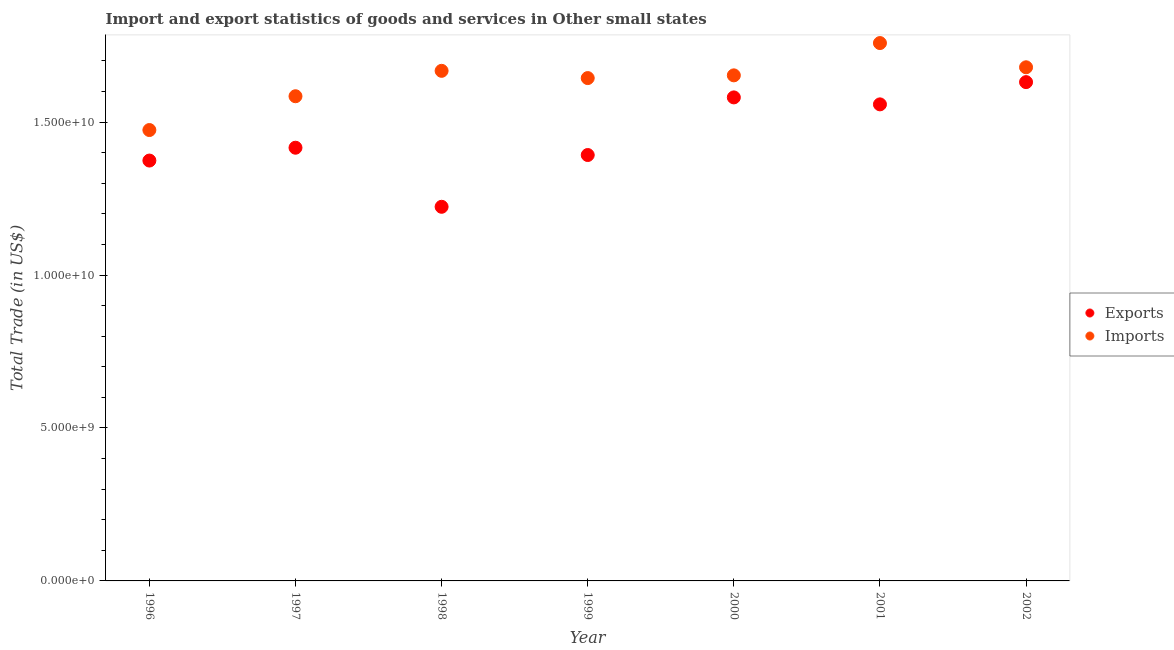How many different coloured dotlines are there?
Your answer should be compact. 2. Is the number of dotlines equal to the number of legend labels?
Make the answer very short. Yes. What is the export of goods and services in 2000?
Make the answer very short. 1.58e+1. Across all years, what is the maximum export of goods and services?
Provide a succinct answer. 1.63e+1. Across all years, what is the minimum export of goods and services?
Give a very brief answer. 1.22e+1. In which year was the imports of goods and services maximum?
Your response must be concise. 2001. In which year was the export of goods and services minimum?
Your answer should be very brief. 1998. What is the total imports of goods and services in the graph?
Provide a short and direct response. 1.15e+11. What is the difference between the imports of goods and services in 2000 and that in 2002?
Keep it short and to the point. -2.64e+08. What is the difference between the export of goods and services in 2001 and the imports of goods and services in 2002?
Your answer should be very brief. -1.21e+09. What is the average imports of goods and services per year?
Offer a terse response. 1.64e+1. In the year 2002, what is the difference between the imports of goods and services and export of goods and services?
Ensure brevity in your answer.  4.85e+08. In how many years, is the imports of goods and services greater than 1000000000 US$?
Your response must be concise. 7. What is the ratio of the export of goods and services in 1999 to that in 2001?
Offer a very short reply. 0.89. What is the difference between the highest and the second highest imports of goods and services?
Offer a terse response. 7.92e+08. What is the difference between the highest and the lowest export of goods and services?
Your answer should be compact. 4.08e+09. Is the sum of the export of goods and services in 1997 and 1999 greater than the maximum imports of goods and services across all years?
Offer a very short reply. Yes. Does the export of goods and services monotonically increase over the years?
Offer a terse response. No. Is the imports of goods and services strictly greater than the export of goods and services over the years?
Your response must be concise. Yes. Is the imports of goods and services strictly less than the export of goods and services over the years?
Offer a very short reply. No. How many dotlines are there?
Offer a very short reply. 2. How many years are there in the graph?
Make the answer very short. 7. Does the graph contain grids?
Your response must be concise. No. Where does the legend appear in the graph?
Your answer should be compact. Center right. How many legend labels are there?
Your answer should be compact. 2. How are the legend labels stacked?
Keep it short and to the point. Vertical. What is the title of the graph?
Provide a short and direct response. Import and export statistics of goods and services in Other small states. What is the label or title of the X-axis?
Give a very brief answer. Year. What is the label or title of the Y-axis?
Provide a short and direct response. Total Trade (in US$). What is the Total Trade (in US$) of Exports in 1996?
Your answer should be compact. 1.37e+1. What is the Total Trade (in US$) of Imports in 1996?
Give a very brief answer. 1.47e+1. What is the Total Trade (in US$) of Exports in 1997?
Your response must be concise. 1.42e+1. What is the Total Trade (in US$) in Imports in 1997?
Make the answer very short. 1.58e+1. What is the Total Trade (in US$) in Exports in 1998?
Ensure brevity in your answer.  1.22e+1. What is the Total Trade (in US$) in Imports in 1998?
Your answer should be compact. 1.67e+1. What is the Total Trade (in US$) of Exports in 1999?
Ensure brevity in your answer.  1.39e+1. What is the Total Trade (in US$) of Imports in 1999?
Keep it short and to the point. 1.64e+1. What is the Total Trade (in US$) in Exports in 2000?
Keep it short and to the point. 1.58e+1. What is the Total Trade (in US$) in Imports in 2000?
Your answer should be very brief. 1.65e+1. What is the Total Trade (in US$) in Exports in 2001?
Your response must be concise. 1.56e+1. What is the Total Trade (in US$) in Imports in 2001?
Your response must be concise. 1.76e+1. What is the Total Trade (in US$) in Exports in 2002?
Offer a terse response. 1.63e+1. What is the Total Trade (in US$) of Imports in 2002?
Give a very brief answer. 1.68e+1. Across all years, what is the maximum Total Trade (in US$) in Exports?
Offer a very short reply. 1.63e+1. Across all years, what is the maximum Total Trade (in US$) of Imports?
Offer a very short reply. 1.76e+1. Across all years, what is the minimum Total Trade (in US$) of Exports?
Provide a short and direct response. 1.22e+1. Across all years, what is the minimum Total Trade (in US$) in Imports?
Your answer should be compact. 1.47e+1. What is the total Total Trade (in US$) of Exports in the graph?
Keep it short and to the point. 1.02e+11. What is the total Total Trade (in US$) in Imports in the graph?
Ensure brevity in your answer.  1.15e+11. What is the difference between the Total Trade (in US$) of Exports in 1996 and that in 1997?
Your answer should be very brief. -4.20e+08. What is the difference between the Total Trade (in US$) of Imports in 1996 and that in 1997?
Make the answer very short. -1.10e+09. What is the difference between the Total Trade (in US$) of Exports in 1996 and that in 1998?
Your answer should be compact. 1.51e+09. What is the difference between the Total Trade (in US$) in Imports in 1996 and that in 1998?
Give a very brief answer. -1.94e+09. What is the difference between the Total Trade (in US$) of Exports in 1996 and that in 1999?
Make the answer very short. -1.81e+08. What is the difference between the Total Trade (in US$) of Imports in 1996 and that in 1999?
Your response must be concise. -1.70e+09. What is the difference between the Total Trade (in US$) of Exports in 1996 and that in 2000?
Your answer should be compact. -2.06e+09. What is the difference between the Total Trade (in US$) of Imports in 1996 and that in 2000?
Offer a terse response. -1.79e+09. What is the difference between the Total Trade (in US$) of Exports in 1996 and that in 2001?
Your response must be concise. -1.84e+09. What is the difference between the Total Trade (in US$) in Imports in 1996 and that in 2001?
Offer a terse response. -2.84e+09. What is the difference between the Total Trade (in US$) of Exports in 1996 and that in 2002?
Provide a short and direct response. -2.56e+09. What is the difference between the Total Trade (in US$) in Imports in 1996 and that in 2002?
Make the answer very short. -2.05e+09. What is the difference between the Total Trade (in US$) in Exports in 1997 and that in 1998?
Make the answer very short. 1.93e+09. What is the difference between the Total Trade (in US$) of Imports in 1997 and that in 1998?
Give a very brief answer. -8.31e+08. What is the difference between the Total Trade (in US$) in Exports in 1997 and that in 1999?
Provide a short and direct response. 2.39e+08. What is the difference between the Total Trade (in US$) of Imports in 1997 and that in 1999?
Keep it short and to the point. -5.94e+08. What is the difference between the Total Trade (in US$) in Exports in 1997 and that in 2000?
Offer a terse response. -1.65e+09. What is the difference between the Total Trade (in US$) of Imports in 1997 and that in 2000?
Your answer should be compact. -6.83e+08. What is the difference between the Total Trade (in US$) in Exports in 1997 and that in 2001?
Ensure brevity in your answer.  -1.42e+09. What is the difference between the Total Trade (in US$) of Imports in 1997 and that in 2001?
Ensure brevity in your answer.  -1.74e+09. What is the difference between the Total Trade (in US$) in Exports in 1997 and that in 2002?
Your response must be concise. -2.15e+09. What is the difference between the Total Trade (in US$) of Imports in 1997 and that in 2002?
Keep it short and to the point. -9.47e+08. What is the difference between the Total Trade (in US$) of Exports in 1998 and that in 1999?
Provide a succinct answer. -1.69e+09. What is the difference between the Total Trade (in US$) of Imports in 1998 and that in 1999?
Your answer should be very brief. 2.37e+08. What is the difference between the Total Trade (in US$) in Exports in 1998 and that in 2000?
Give a very brief answer. -3.58e+09. What is the difference between the Total Trade (in US$) in Imports in 1998 and that in 2000?
Make the answer very short. 1.48e+08. What is the difference between the Total Trade (in US$) in Exports in 1998 and that in 2001?
Ensure brevity in your answer.  -3.35e+09. What is the difference between the Total Trade (in US$) of Imports in 1998 and that in 2001?
Your answer should be compact. -9.08e+08. What is the difference between the Total Trade (in US$) in Exports in 1998 and that in 2002?
Ensure brevity in your answer.  -4.08e+09. What is the difference between the Total Trade (in US$) in Imports in 1998 and that in 2002?
Provide a short and direct response. -1.16e+08. What is the difference between the Total Trade (in US$) in Exports in 1999 and that in 2000?
Provide a short and direct response. -1.88e+09. What is the difference between the Total Trade (in US$) in Imports in 1999 and that in 2000?
Provide a short and direct response. -8.91e+07. What is the difference between the Total Trade (in US$) in Exports in 1999 and that in 2001?
Your answer should be compact. -1.66e+09. What is the difference between the Total Trade (in US$) in Imports in 1999 and that in 2001?
Ensure brevity in your answer.  -1.15e+09. What is the difference between the Total Trade (in US$) of Exports in 1999 and that in 2002?
Offer a very short reply. -2.38e+09. What is the difference between the Total Trade (in US$) of Imports in 1999 and that in 2002?
Your answer should be compact. -3.53e+08. What is the difference between the Total Trade (in US$) of Exports in 2000 and that in 2001?
Keep it short and to the point. 2.28e+08. What is the difference between the Total Trade (in US$) of Imports in 2000 and that in 2001?
Your response must be concise. -1.06e+09. What is the difference between the Total Trade (in US$) in Exports in 2000 and that in 2002?
Offer a very short reply. -5.00e+08. What is the difference between the Total Trade (in US$) of Imports in 2000 and that in 2002?
Your answer should be very brief. -2.64e+08. What is the difference between the Total Trade (in US$) of Exports in 2001 and that in 2002?
Offer a very short reply. -7.28e+08. What is the difference between the Total Trade (in US$) in Imports in 2001 and that in 2002?
Your answer should be compact. 7.92e+08. What is the difference between the Total Trade (in US$) of Exports in 1996 and the Total Trade (in US$) of Imports in 1997?
Make the answer very short. -2.10e+09. What is the difference between the Total Trade (in US$) of Exports in 1996 and the Total Trade (in US$) of Imports in 1998?
Ensure brevity in your answer.  -2.93e+09. What is the difference between the Total Trade (in US$) in Exports in 1996 and the Total Trade (in US$) in Imports in 1999?
Offer a terse response. -2.70e+09. What is the difference between the Total Trade (in US$) of Exports in 1996 and the Total Trade (in US$) of Imports in 2000?
Your response must be concise. -2.79e+09. What is the difference between the Total Trade (in US$) in Exports in 1996 and the Total Trade (in US$) in Imports in 2001?
Offer a terse response. -3.84e+09. What is the difference between the Total Trade (in US$) of Exports in 1996 and the Total Trade (in US$) of Imports in 2002?
Ensure brevity in your answer.  -3.05e+09. What is the difference between the Total Trade (in US$) of Exports in 1997 and the Total Trade (in US$) of Imports in 1998?
Your response must be concise. -2.51e+09. What is the difference between the Total Trade (in US$) in Exports in 1997 and the Total Trade (in US$) in Imports in 1999?
Offer a terse response. -2.28e+09. What is the difference between the Total Trade (in US$) in Exports in 1997 and the Total Trade (in US$) in Imports in 2000?
Offer a terse response. -2.37e+09. What is the difference between the Total Trade (in US$) in Exports in 1997 and the Total Trade (in US$) in Imports in 2001?
Your answer should be compact. -3.42e+09. What is the difference between the Total Trade (in US$) in Exports in 1997 and the Total Trade (in US$) in Imports in 2002?
Make the answer very short. -2.63e+09. What is the difference between the Total Trade (in US$) in Exports in 1998 and the Total Trade (in US$) in Imports in 1999?
Provide a succinct answer. -4.21e+09. What is the difference between the Total Trade (in US$) in Exports in 1998 and the Total Trade (in US$) in Imports in 2000?
Your response must be concise. -4.30e+09. What is the difference between the Total Trade (in US$) of Exports in 1998 and the Total Trade (in US$) of Imports in 2001?
Offer a very short reply. -5.35e+09. What is the difference between the Total Trade (in US$) in Exports in 1998 and the Total Trade (in US$) in Imports in 2002?
Keep it short and to the point. -4.56e+09. What is the difference between the Total Trade (in US$) in Exports in 1999 and the Total Trade (in US$) in Imports in 2000?
Offer a very short reply. -2.60e+09. What is the difference between the Total Trade (in US$) in Exports in 1999 and the Total Trade (in US$) in Imports in 2001?
Your answer should be very brief. -3.66e+09. What is the difference between the Total Trade (in US$) of Exports in 1999 and the Total Trade (in US$) of Imports in 2002?
Your answer should be very brief. -2.87e+09. What is the difference between the Total Trade (in US$) in Exports in 2000 and the Total Trade (in US$) in Imports in 2001?
Make the answer very short. -1.78e+09. What is the difference between the Total Trade (in US$) of Exports in 2000 and the Total Trade (in US$) of Imports in 2002?
Keep it short and to the point. -9.85e+08. What is the difference between the Total Trade (in US$) in Exports in 2001 and the Total Trade (in US$) in Imports in 2002?
Offer a terse response. -1.21e+09. What is the average Total Trade (in US$) in Exports per year?
Offer a very short reply. 1.45e+1. What is the average Total Trade (in US$) of Imports per year?
Offer a terse response. 1.64e+1. In the year 1996, what is the difference between the Total Trade (in US$) in Exports and Total Trade (in US$) in Imports?
Offer a very short reply. -9.98e+08. In the year 1997, what is the difference between the Total Trade (in US$) in Exports and Total Trade (in US$) in Imports?
Offer a very short reply. -1.68e+09. In the year 1998, what is the difference between the Total Trade (in US$) in Exports and Total Trade (in US$) in Imports?
Give a very brief answer. -4.45e+09. In the year 1999, what is the difference between the Total Trade (in US$) of Exports and Total Trade (in US$) of Imports?
Your answer should be compact. -2.52e+09. In the year 2000, what is the difference between the Total Trade (in US$) of Exports and Total Trade (in US$) of Imports?
Ensure brevity in your answer.  -7.21e+08. In the year 2001, what is the difference between the Total Trade (in US$) of Exports and Total Trade (in US$) of Imports?
Your response must be concise. -2.00e+09. In the year 2002, what is the difference between the Total Trade (in US$) of Exports and Total Trade (in US$) of Imports?
Your answer should be very brief. -4.85e+08. What is the ratio of the Total Trade (in US$) of Exports in 1996 to that in 1997?
Offer a terse response. 0.97. What is the ratio of the Total Trade (in US$) in Imports in 1996 to that in 1997?
Your response must be concise. 0.93. What is the ratio of the Total Trade (in US$) of Exports in 1996 to that in 1998?
Keep it short and to the point. 1.12. What is the ratio of the Total Trade (in US$) of Imports in 1996 to that in 1998?
Make the answer very short. 0.88. What is the ratio of the Total Trade (in US$) of Imports in 1996 to that in 1999?
Keep it short and to the point. 0.9. What is the ratio of the Total Trade (in US$) of Exports in 1996 to that in 2000?
Provide a succinct answer. 0.87. What is the ratio of the Total Trade (in US$) of Imports in 1996 to that in 2000?
Ensure brevity in your answer.  0.89. What is the ratio of the Total Trade (in US$) in Exports in 1996 to that in 2001?
Your answer should be compact. 0.88. What is the ratio of the Total Trade (in US$) of Imports in 1996 to that in 2001?
Your response must be concise. 0.84. What is the ratio of the Total Trade (in US$) of Exports in 1996 to that in 2002?
Provide a succinct answer. 0.84. What is the ratio of the Total Trade (in US$) in Imports in 1996 to that in 2002?
Make the answer very short. 0.88. What is the ratio of the Total Trade (in US$) in Exports in 1997 to that in 1998?
Give a very brief answer. 1.16. What is the ratio of the Total Trade (in US$) of Imports in 1997 to that in 1998?
Provide a succinct answer. 0.95. What is the ratio of the Total Trade (in US$) of Exports in 1997 to that in 1999?
Give a very brief answer. 1.02. What is the ratio of the Total Trade (in US$) in Imports in 1997 to that in 1999?
Provide a succinct answer. 0.96. What is the ratio of the Total Trade (in US$) in Exports in 1997 to that in 2000?
Your answer should be compact. 0.9. What is the ratio of the Total Trade (in US$) of Imports in 1997 to that in 2000?
Your response must be concise. 0.96. What is the ratio of the Total Trade (in US$) in Exports in 1997 to that in 2001?
Provide a short and direct response. 0.91. What is the ratio of the Total Trade (in US$) in Imports in 1997 to that in 2001?
Your response must be concise. 0.9. What is the ratio of the Total Trade (in US$) in Exports in 1997 to that in 2002?
Keep it short and to the point. 0.87. What is the ratio of the Total Trade (in US$) in Imports in 1997 to that in 2002?
Keep it short and to the point. 0.94. What is the ratio of the Total Trade (in US$) in Exports in 1998 to that in 1999?
Your response must be concise. 0.88. What is the ratio of the Total Trade (in US$) in Imports in 1998 to that in 1999?
Provide a short and direct response. 1.01. What is the ratio of the Total Trade (in US$) in Exports in 1998 to that in 2000?
Provide a succinct answer. 0.77. What is the ratio of the Total Trade (in US$) of Imports in 1998 to that in 2000?
Ensure brevity in your answer.  1.01. What is the ratio of the Total Trade (in US$) in Exports in 1998 to that in 2001?
Your response must be concise. 0.79. What is the ratio of the Total Trade (in US$) in Imports in 1998 to that in 2001?
Make the answer very short. 0.95. What is the ratio of the Total Trade (in US$) of Exports in 1998 to that in 2002?
Your response must be concise. 0.75. What is the ratio of the Total Trade (in US$) of Exports in 1999 to that in 2000?
Provide a succinct answer. 0.88. What is the ratio of the Total Trade (in US$) in Exports in 1999 to that in 2001?
Provide a succinct answer. 0.89. What is the ratio of the Total Trade (in US$) of Imports in 1999 to that in 2001?
Provide a short and direct response. 0.93. What is the ratio of the Total Trade (in US$) of Exports in 1999 to that in 2002?
Your answer should be very brief. 0.85. What is the ratio of the Total Trade (in US$) of Exports in 2000 to that in 2001?
Your answer should be compact. 1.01. What is the ratio of the Total Trade (in US$) in Imports in 2000 to that in 2001?
Provide a succinct answer. 0.94. What is the ratio of the Total Trade (in US$) in Exports in 2000 to that in 2002?
Give a very brief answer. 0.97. What is the ratio of the Total Trade (in US$) of Imports in 2000 to that in 2002?
Give a very brief answer. 0.98. What is the ratio of the Total Trade (in US$) in Exports in 2001 to that in 2002?
Your answer should be very brief. 0.96. What is the ratio of the Total Trade (in US$) in Imports in 2001 to that in 2002?
Ensure brevity in your answer.  1.05. What is the difference between the highest and the second highest Total Trade (in US$) in Exports?
Your response must be concise. 5.00e+08. What is the difference between the highest and the second highest Total Trade (in US$) in Imports?
Offer a very short reply. 7.92e+08. What is the difference between the highest and the lowest Total Trade (in US$) of Exports?
Ensure brevity in your answer.  4.08e+09. What is the difference between the highest and the lowest Total Trade (in US$) of Imports?
Provide a short and direct response. 2.84e+09. 